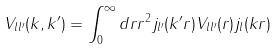<formula> <loc_0><loc_0><loc_500><loc_500>V _ { l l ^ { \prime } } ( k , k ^ { \prime } ) = \int _ { 0 } ^ { \infty } d r r ^ { 2 } j _ { l ^ { \prime } } ( k ^ { \prime } r ) V _ { l l ^ { \prime } } ( r ) j _ { l } ( k r )</formula> 